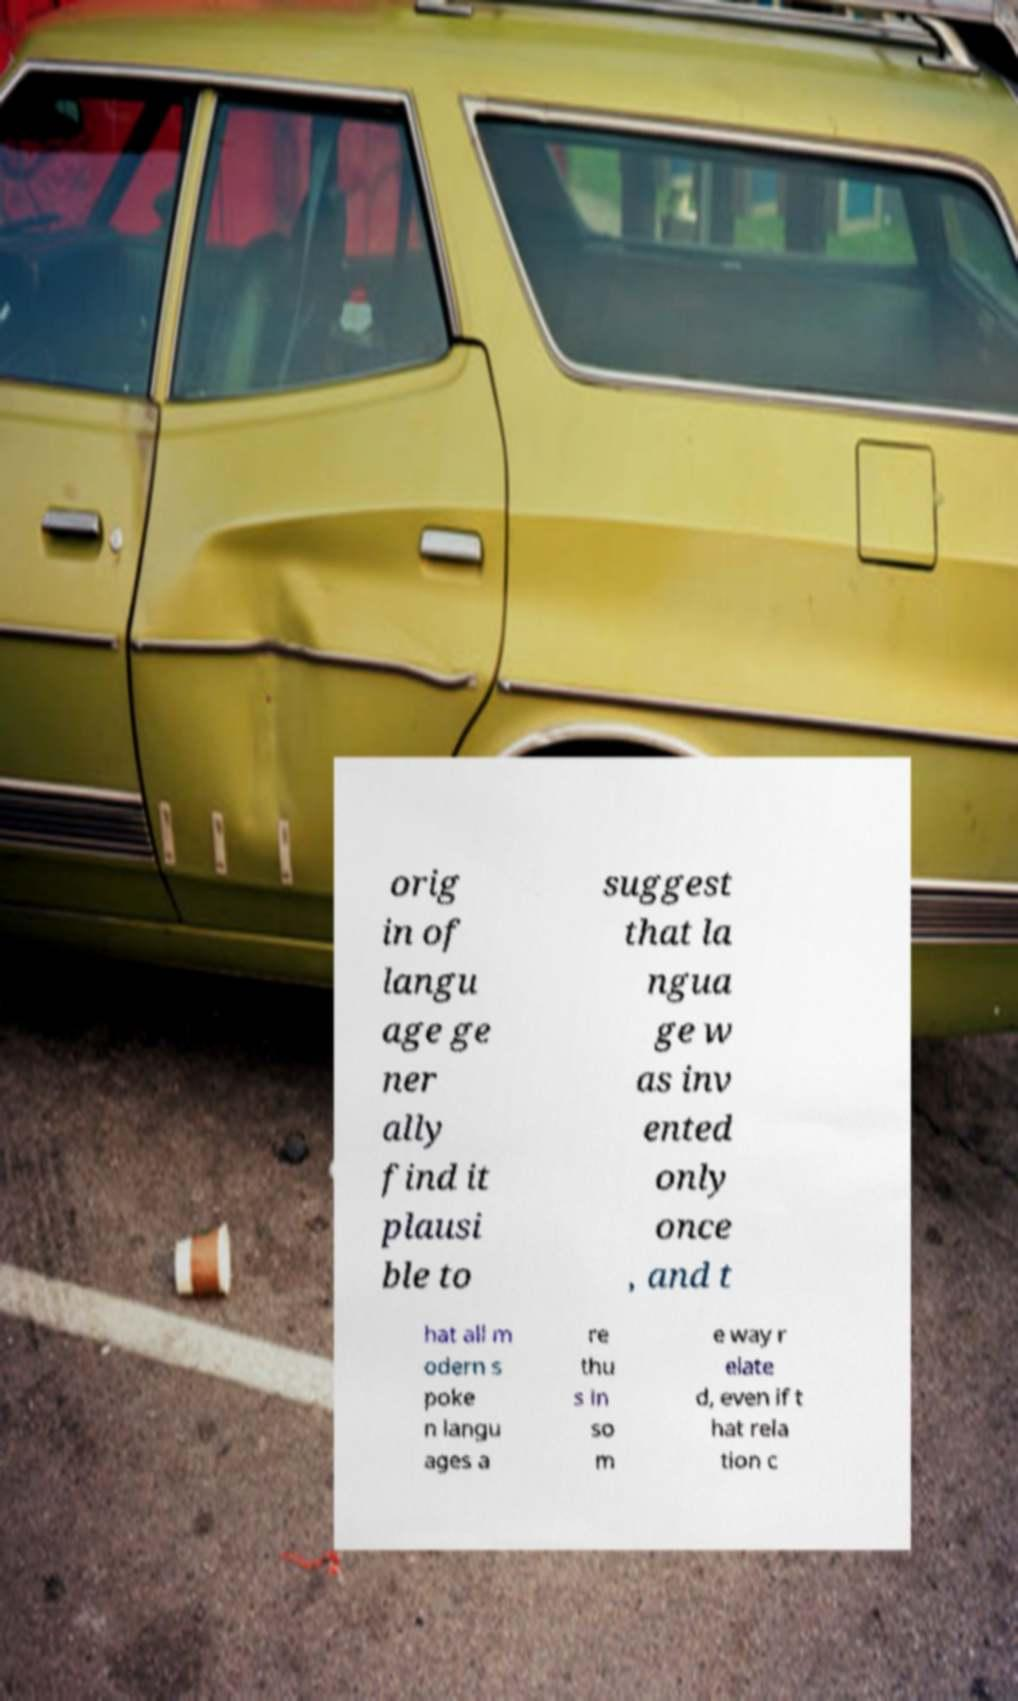Please identify and transcribe the text found in this image. orig in of langu age ge ner ally find it plausi ble to suggest that la ngua ge w as inv ented only once , and t hat all m odern s poke n langu ages a re thu s in so m e way r elate d, even if t hat rela tion c 